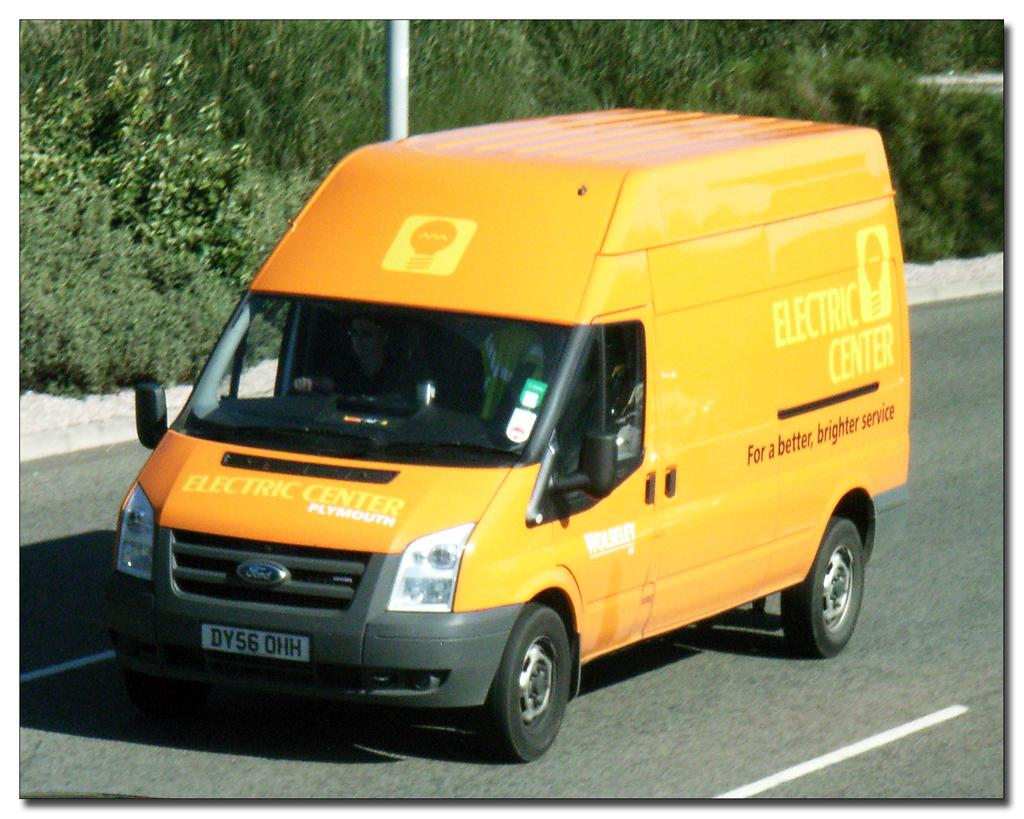<image>
Offer a succinct explanation of the picture presented. A yellow Electric Center van with the slogan "For a better, brighter service" on the side, drives down the road. 